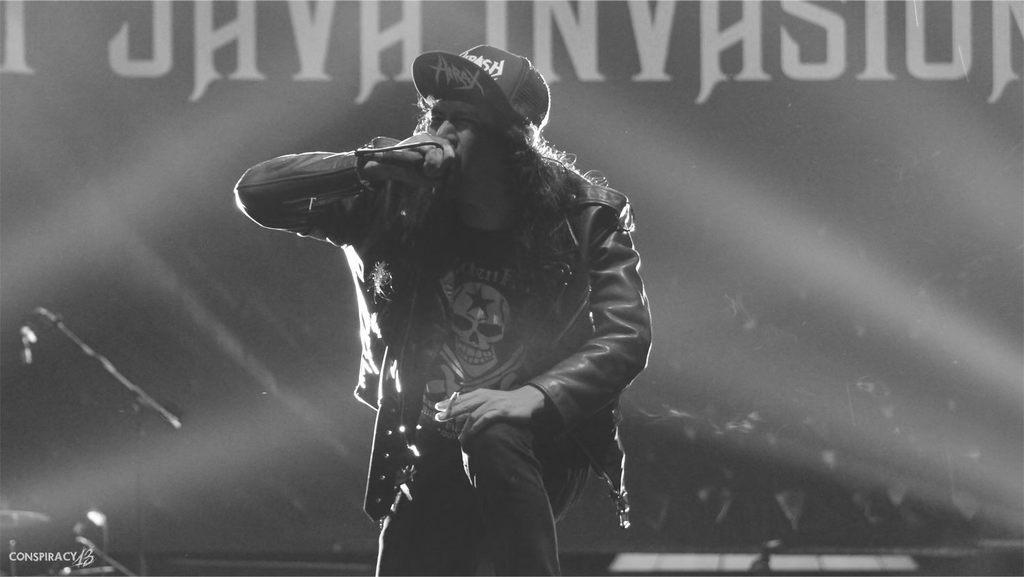What is the main subject of the image? There is a man standing in the middle of the image. What is the man wearing on his head? The man is wearing a hat. What can be seen in the background of the image? There is a curtain in the background of the image. What is written or depicted on the curtain? There is text on the curtain. What type of fruit is hanging from the man's hat in the image? There is no fruit hanging from the man's hat in the image. What insurance policy does the man have, as indicated by the text on the curtain? The text on the curtain does not mention any insurance policy; it only states that there is text present. 